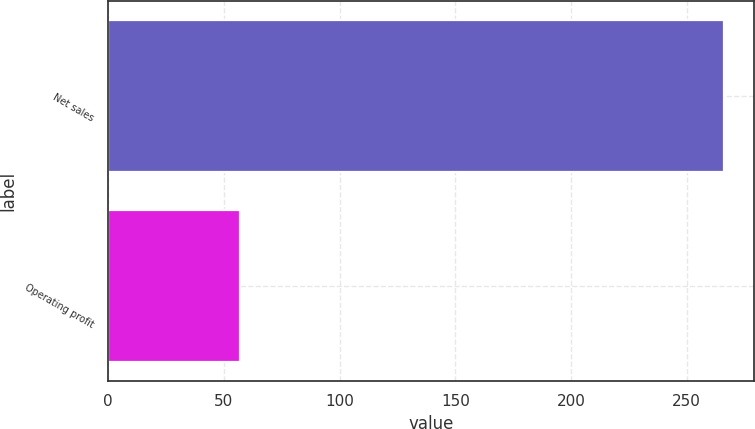Convert chart. <chart><loc_0><loc_0><loc_500><loc_500><bar_chart><fcel>Net sales<fcel>Operating profit<nl><fcel>266<fcel>57<nl></chart> 